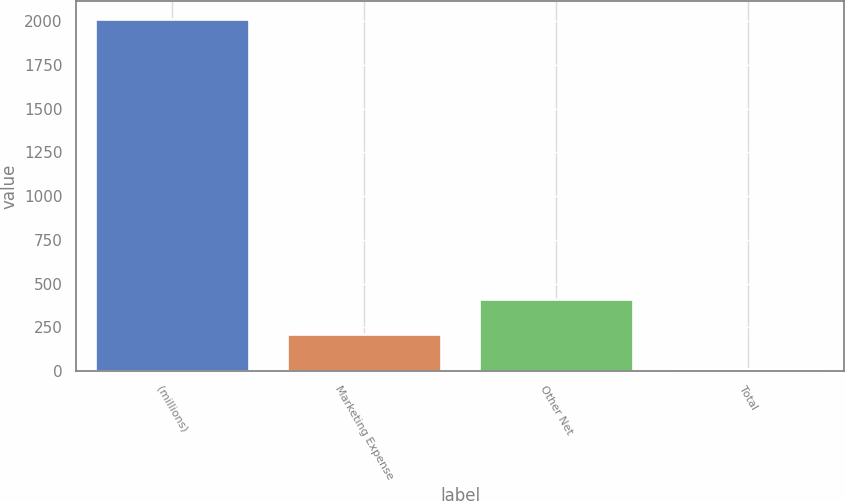Convert chart. <chart><loc_0><loc_0><loc_500><loc_500><bar_chart><fcel>(millions)<fcel>Marketing Expense<fcel>Other Net<fcel>Total<nl><fcel>2014<fcel>208.6<fcel>409.2<fcel>8<nl></chart> 